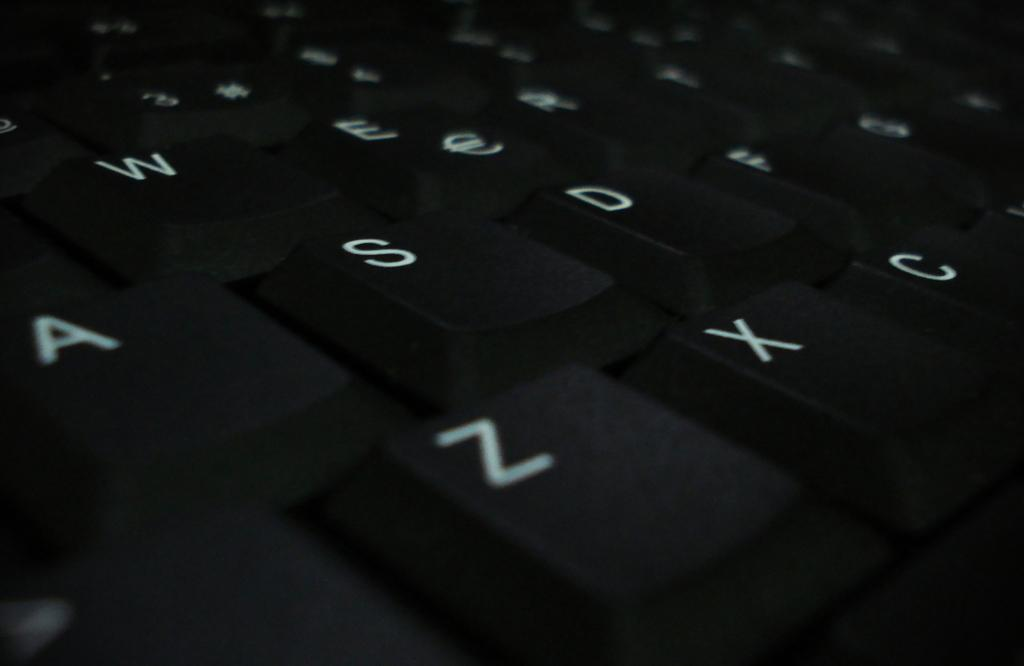<image>
Create a compact narrative representing the image presented. A close up of a black keyboard with the bottom row of letters being Z, X, and C. 